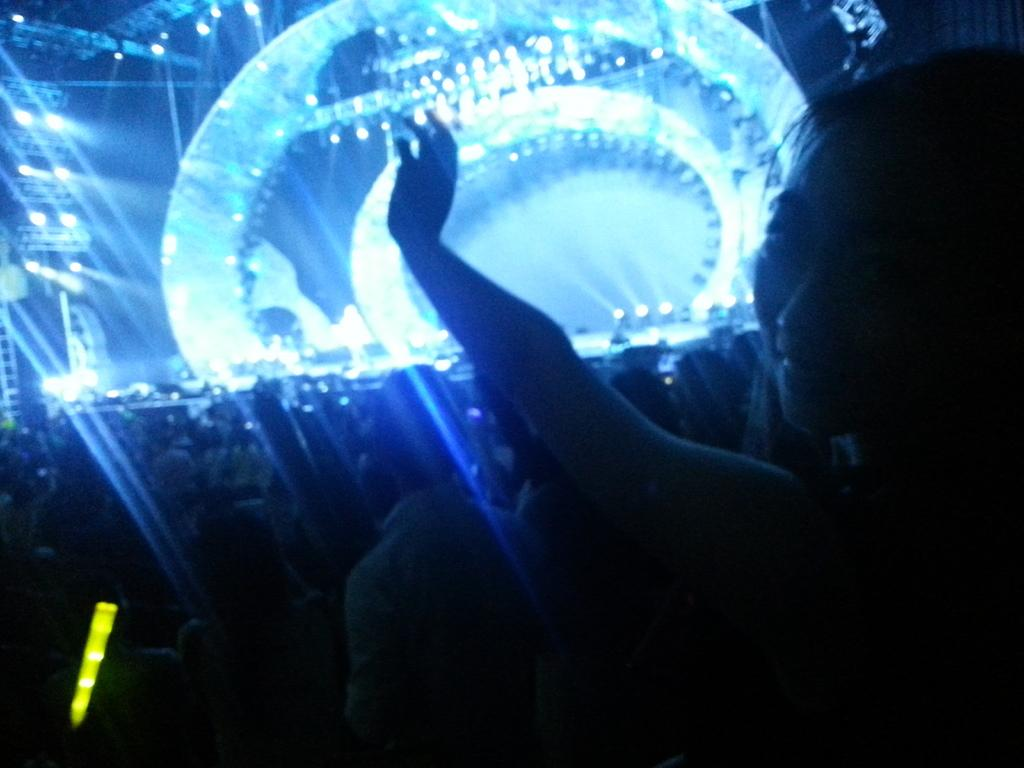Who is the main subject in the foreground of the image? There is a woman in the foreground of the image. Where is the woman located in relation to the image? The woman is on the right side of the image. What can be seen in the background of the image? There are people, lights on the stage, and poles in the background of the image. What type of toys can be seen hanging from the poles in the image? There are no toys visible in the image; only people, lights on the stage, and poles can be seen in the background. 